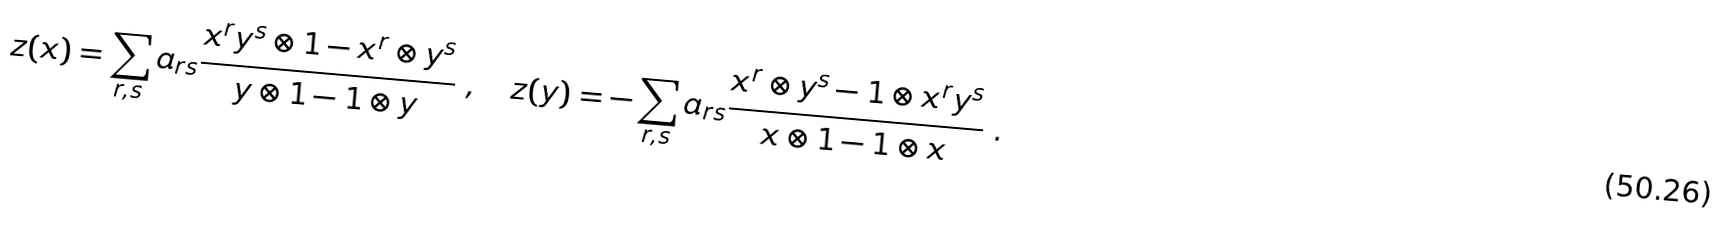<formula> <loc_0><loc_0><loc_500><loc_500>z ( x ) = \sum _ { r , s } a _ { r s } \frac { x ^ { r } y ^ { s } \otimes 1 - x ^ { r } \otimes y ^ { s } } { y \otimes 1 - 1 \otimes y } \ , \quad z ( y ) = - \sum _ { r , s } a _ { r s } \frac { x ^ { r } \otimes y ^ { s } - 1 \otimes x ^ { r } y ^ { s } } { x \otimes 1 - 1 \otimes x } \ .</formula> 